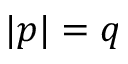Convert formula to latex. <formula><loc_0><loc_0><loc_500><loc_500>| p | = q</formula> 